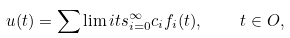Convert formula to latex. <formula><loc_0><loc_0><loc_500><loc_500>u ( t ) = \sum \lim i t s _ { i = 0 } ^ { \infty } c _ { i } f _ { i } ( t ) , \quad t \in O ,</formula> 